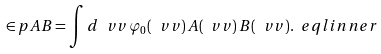Convert formula to latex. <formula><loc_0><loc_0><loc_500><loc_500>\in p { A } { B } = \int d \ v v \, \varphi _ { 0 } ( \ v v ) \, A ( \ v v ) \, B ( \ v v ) . \ e q l { i n n e r }</formula> 